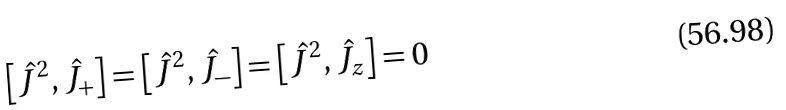<formula> <loc_0><loc_0><loc_500><loc_500>\left [ { \hat { J } } ^ { 2 } , { \hat { J } } _ { + } \right ] = \left [ { \hat { J } } ^ { 2 } , { \hat { J } } _ { - } \right ] = \left [ { \hat { J } } ^ { 2 } , { \hat { J } } _ { z } \right ] = 0</formula> 